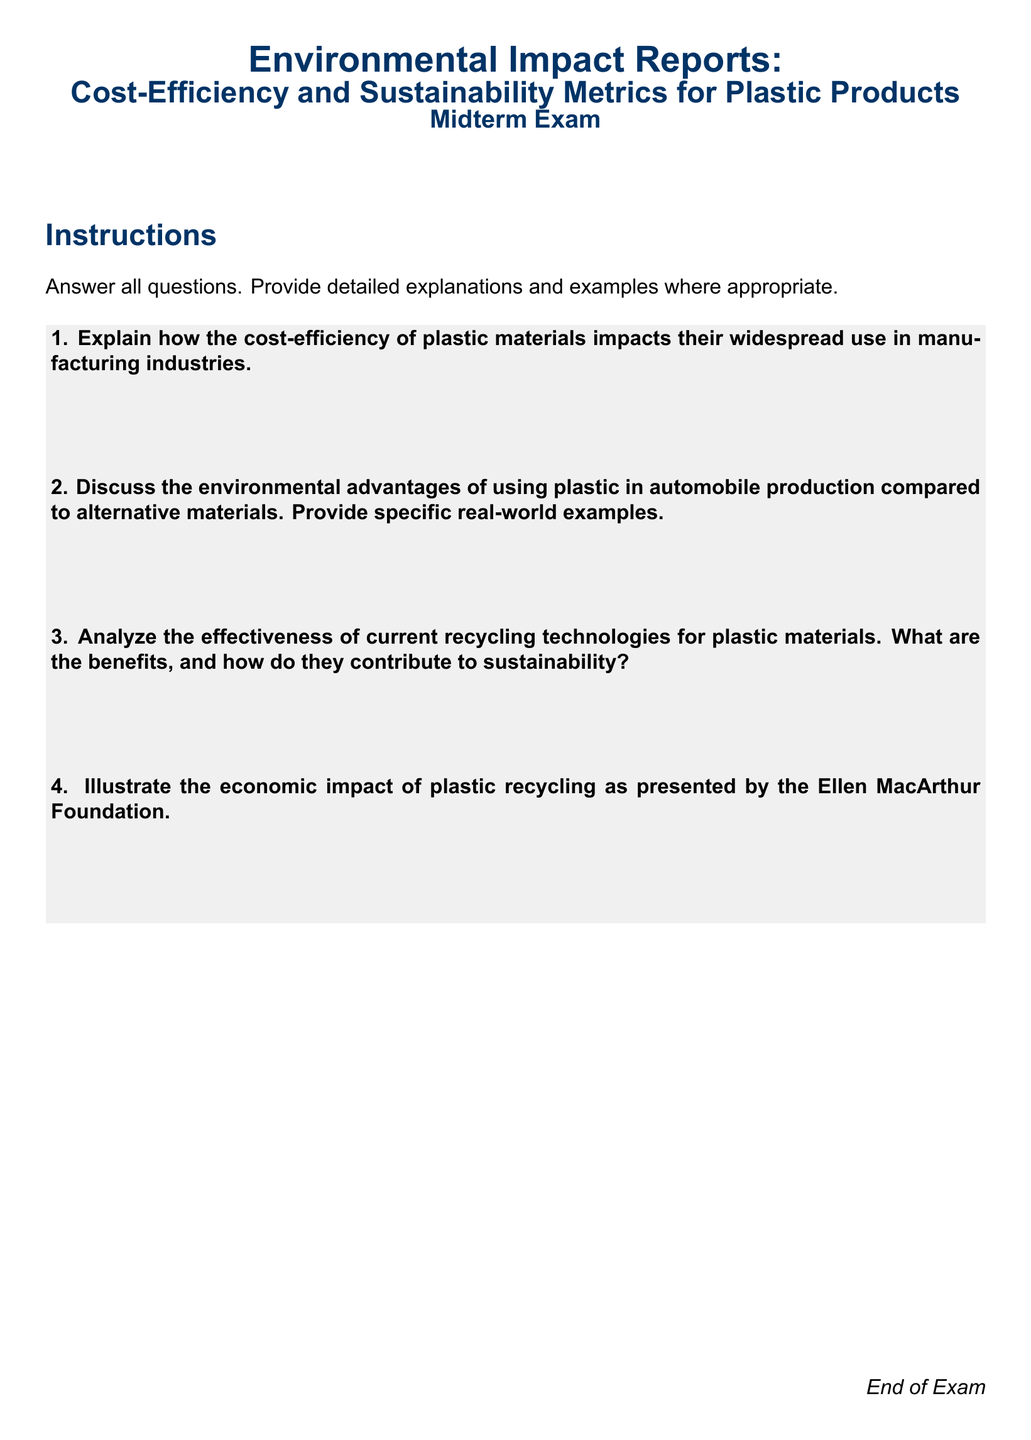What is the main focus of the midterm exam? The main focus of the midterm exam is on Environmental Impact Reports, specifically regarding Cost-Efficiency and Sustainability Metrics for Plastic Products.
Answer: Environmental Impact Reports: Cost-Efficiency and Sustainability Metrics for Plastic Products How many questions are in the midterm exam? The midterm exam contains a total of four questions that need to be answered.
Answer: Four What is the color used for the headers in the document? The color used for the headers in the document is dark blue, specifically defined by an RGB value.
Answer: Dark blue What does the student need to do for each question? Students are instructed to provide detailed explanations and examples where appropriate for each question.
Answer: Provide detailed explanations and examples Who presented the economic impact of plastic recycling? The Ellen MacArthur Foundation is mentioned as the source for illustrating the economic impact of plastic recycling in the document.
Answer: Ellen MacArthur Foundation What type of questions can be found in the midterm exam? The midterm exam features short-answer questions that require various types of responses, including explanations and examples.
Answer: Short-answer questions What is the document type of this examination? This examination is a midterm exam, as indicated in the document title.
Answer: Midterm exam What is the primary subject of question 2? The primary subject of question 2 is the environmental advantages of using plastic in automobile production compared to alternative materials.
Answer: Environmental advantages of using plastic in automobile production 